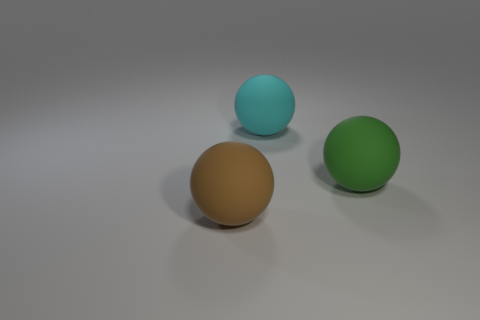The rubber sphere that is in front of the green sphere in front of the large ball that is behind the green rubber thing is what color?
Offer a terse response. Brown. How many other big spheres are the same material as the big green sphere?
Offer a terse response. 2. Do the thing behind the green ball and the large green object have the same size?
Your answer should be compact. Yes. There is a green matte thing; how many large cyan things are right of it?
Provide a succinct answer. 0. Is there a large blue matte cylinder?
Ensure brevity in your answer.  No. How big is the brown rubber thing left of the object right of the ball behind the green sphere?
Give a very brief answer. Large. How many other things are the same size as the cyan ball?
Offer a terse response. 2. How big is the brown matte ball in front of the green rubber ball?
Provide a succinct answer. Large. Are the object that is right of the cyan ball and the large brown object made of the same material?
Give a very brief answer. Yes. How many big matte objects are in front of the large green thing and to the right of the large brown matte sphere?
Provide a succinct answer. 0. 